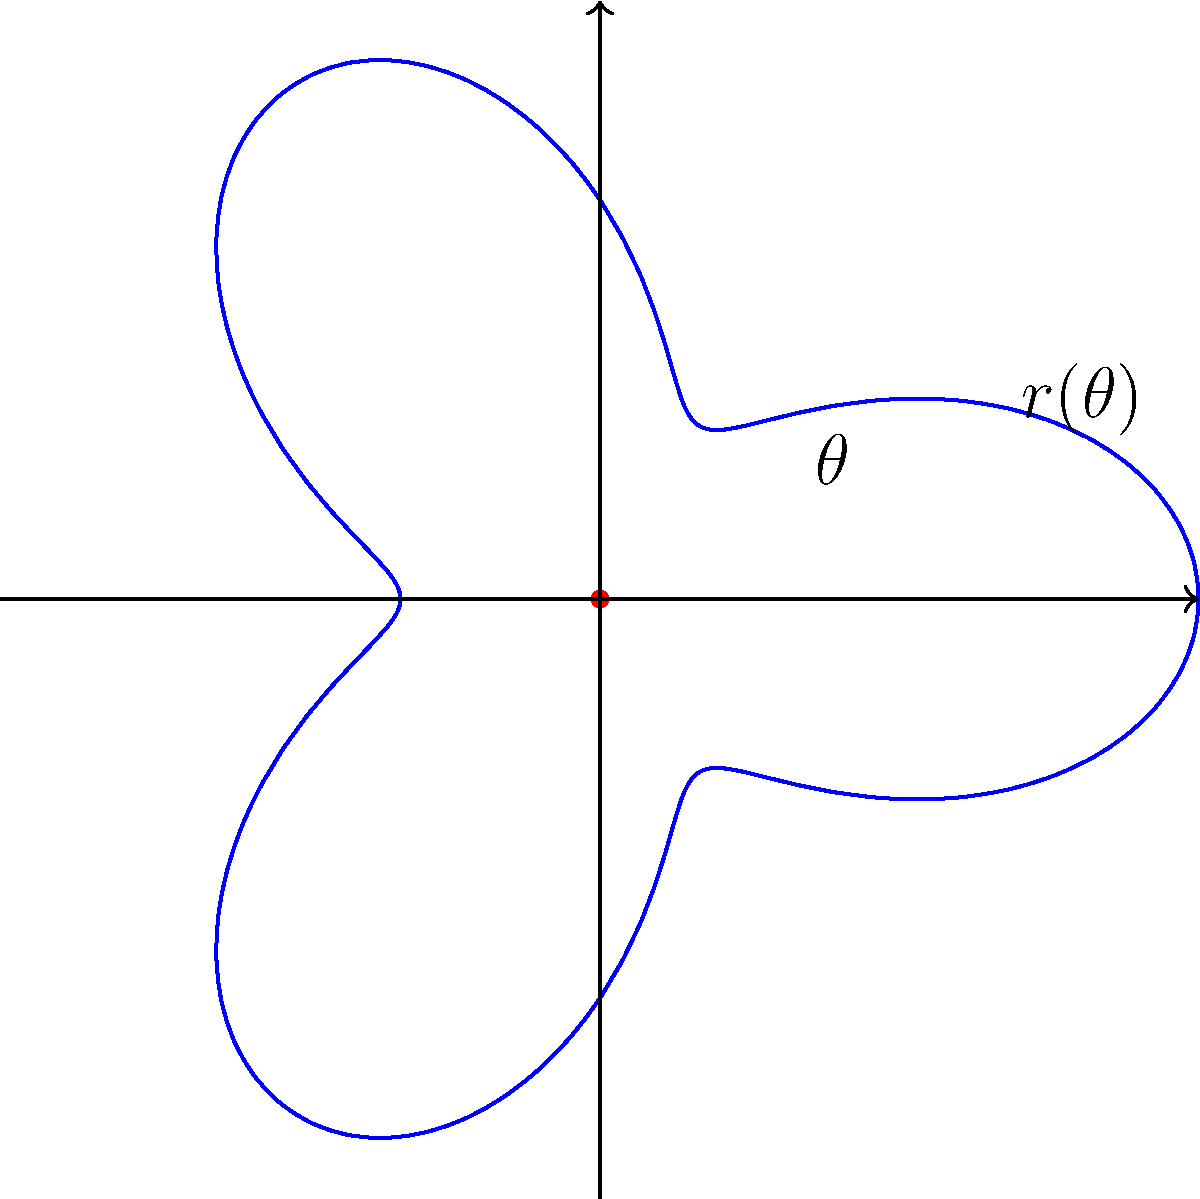In circular breathing techniques, the air flow rate can be modeled using polar coordinates. The function $r(\theta) = 2 + \cos(3\theta)$ describes the air flow rate (in liters per minute) as a function of the breathing cycle angle $\theta$ (in radians). What is the maximum air flow rate achieved during one complete breathing cycle? To find the maximum air flow rate, we need to follow these steps:

1) The air flow rate is given by the function $r(\theta) = 2 + \cos(3\theta)$.

2) The maximum value will occur when $\cos(3\theta)$ reaches its maximum value of 1.

3) Recall that the maximum value of cosine is 1, which occurs when its argument is a multiple of $2\pi$.

4) So, we need to solve: $3\theta = 2\pi n$, where $n$ is an integer.

5) The smallest positive value of $\theta$ that satisfies this is when $n=1$:
   $\theta = \frac{2\pi}{3}$

6) However, we don't actually need to calculate this $\theta$ value. We just need to know that at this point, $\cos(3\theta) = 1$.

7) Therefore, the maximum value of $r(\theta)$ is:
   $r_{max} = 2 + 1 = 3$

8) This means the maximum air flow rate is 3 liters per minute.
Answer: 3 liters per minute 